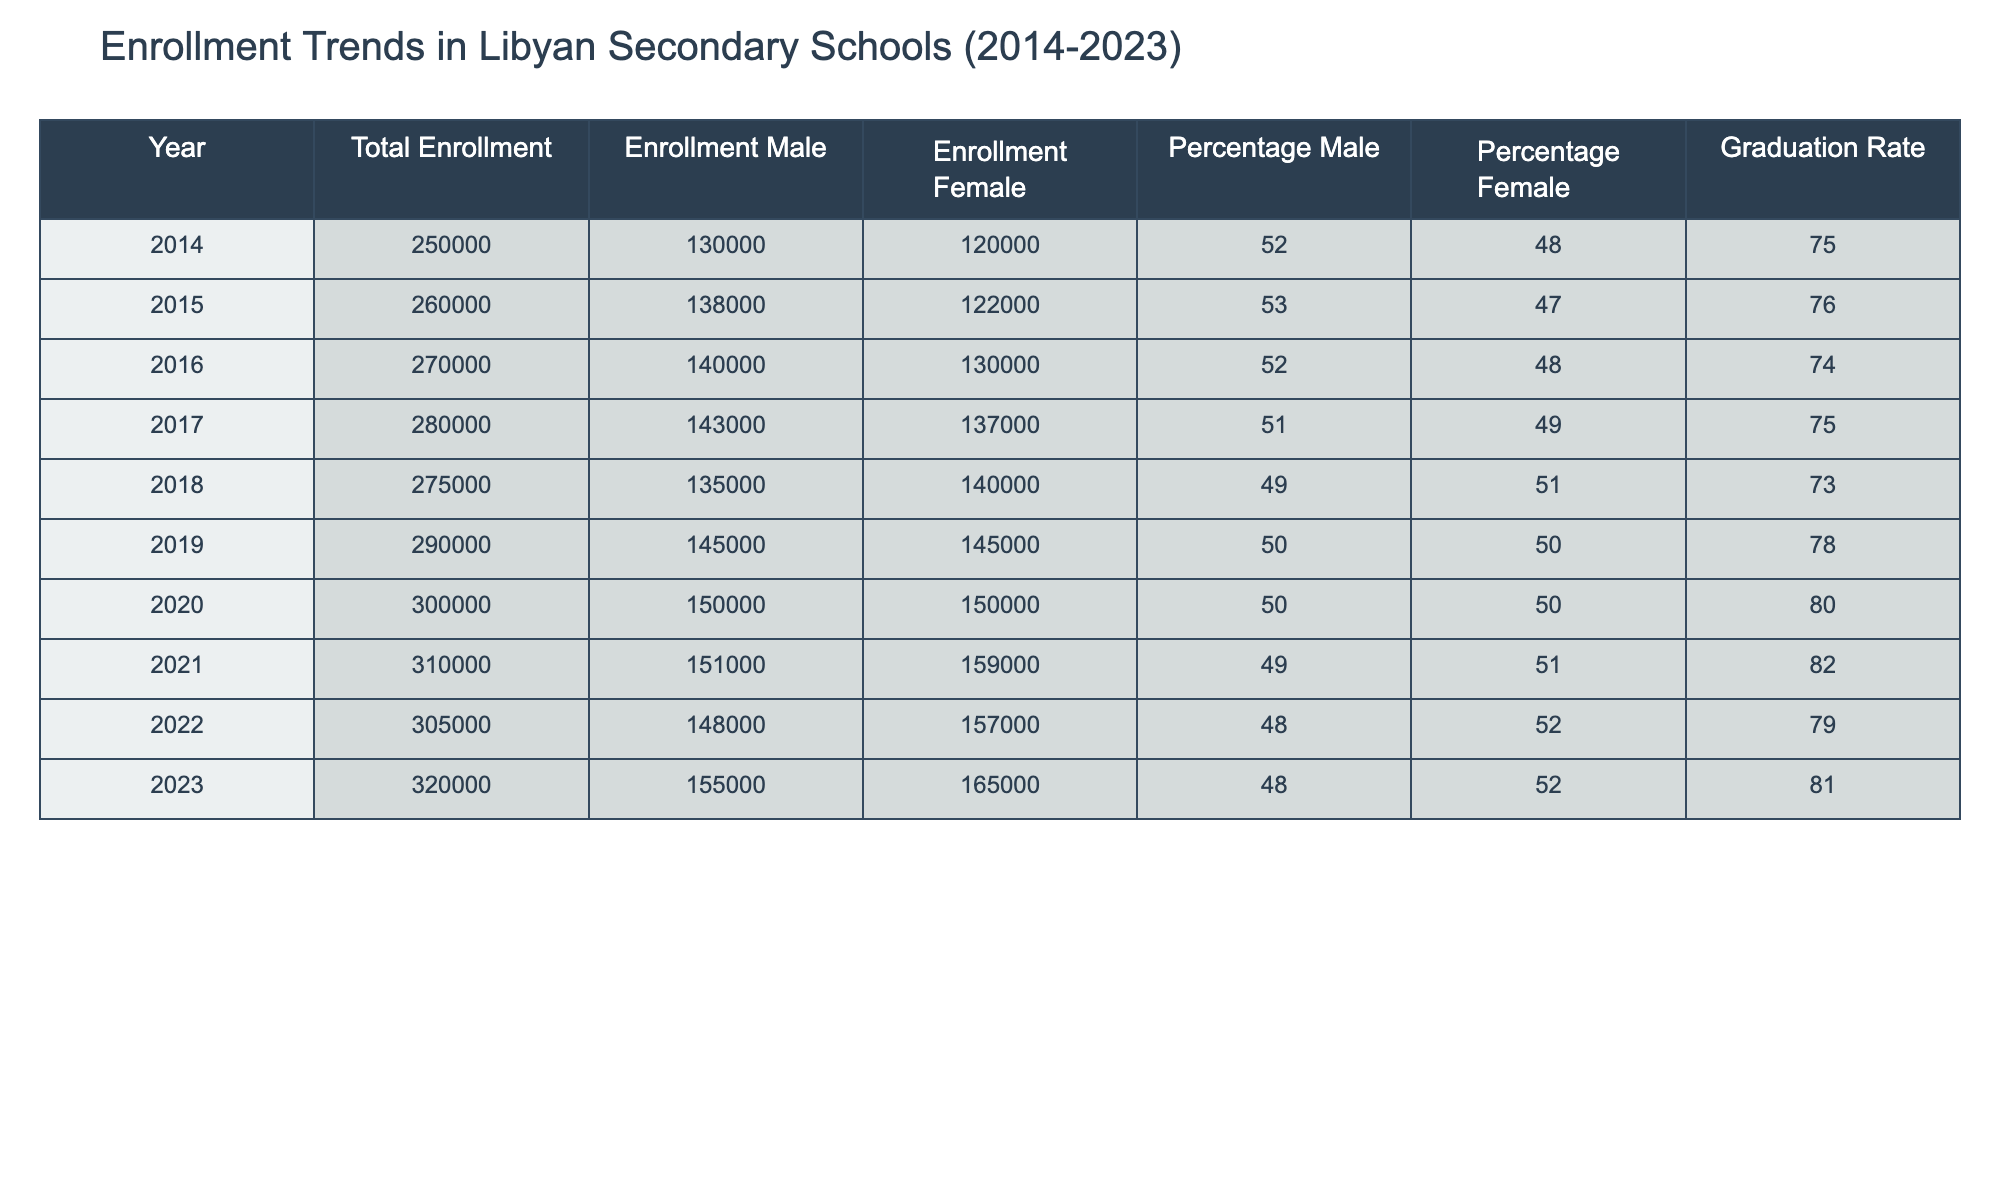What was the total enrollment in Libyan secondary schools in 2020? The table indicates that the total enrollment in Libyan secondary schools for the year 2020 is 300,000. This value can be found directly under the 'Total Enrollment' column for the year 2020.
Answer: 300,000 In which year did the enrollment of females exceed that of males for the first time? By examining the 'Enrollment Male' and 'Enrollment Female' columns, it is evident that females outnumbered males for the first time in 2018. In that year, the enrollment figures were 135,000 for males and 140,000 for females.
Answer: 2018 What was the percentage of female enrollment in 2015? For the year 2015, the 'Percentage Female' column indicates that the percentage of female enrollment was 47%. This value can be retrieved directly from the table.
Answer: 47% How many more males than females were enrolled in 2021? To find this, we subtract the female enrollment from the male enrollment in 2021. The values are 151,000 for males and 159,000 for females. Thus, 151,000 - 159,000 = -8,000, indicating there were 8,000 more females than males.
Answer: 8,000 What is the average total enrollment over the whole decade? To calculate the average total enrollment, we sum the total enrollments from each year (250,000 + 260,000 + 270,000 + 280,000 + 275,000 + 290,000 + 300,000 + 310,000 + 305,000 + 320,000 = 2,770,000) and then divide by the number of years (10). Therefore, the average is 2,770,000 / 10 = 277,000.
Answer: 277,000 Did the graduation rate improve overall during the decade? By analyzing the 'Graduation Rate' column for each year, 2014 started with a graduation rate of 75% and fluctuated, reaching a peak of 82% in 2021 before declining to 79% in 2022 and recovering to 81% in 2023. Therefore, the overall trend shows an improvement from the starting value in 2014, especially in 2021.
Answer: Yes In what year did the total enrollment reach its peak? The total enrollment reached its peak in 2023, where the figure is 320,000, as indicated in the 'Total Enrollment' column. This is the highest value listed amongst all years.
Answer: 2023 What is the difference in graduation rates between 2014 and 2023? To find this difference, we subtract the graduation rate of 2014 from that of 2023. The values are 75% for 2014 and 81% for 2023. Thus, 81% - 75% = 6%.
Answer: 6% 